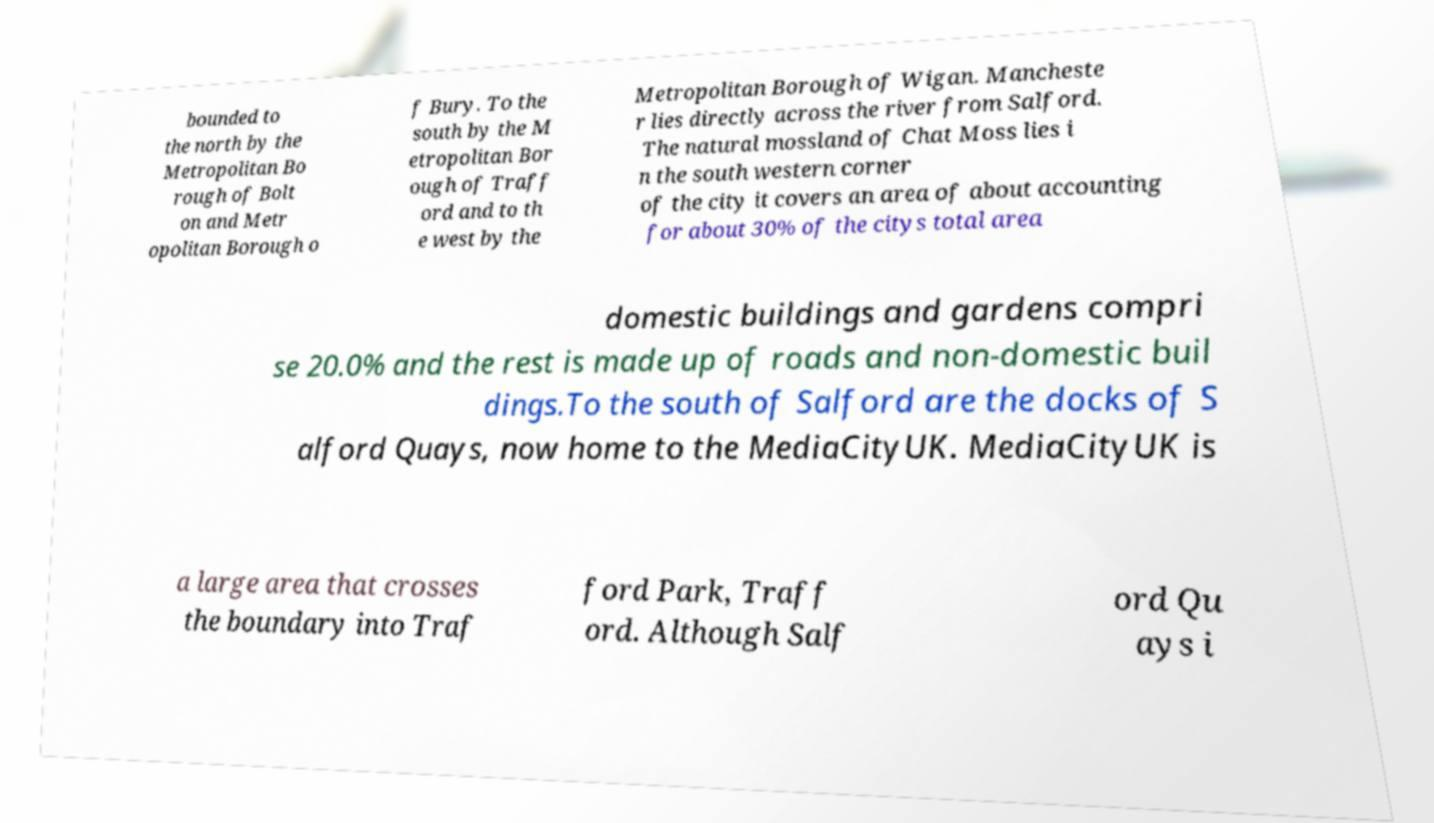Please identify and transcribe the text found in this image. bounded to the north by the Metropolitan Bo rough of Bolt on and Metr opolitan Borough o f Bury. To the south by the M etropolitan Bor ough of Traff ord and to th e west by the Metropolitan Borough of Wigan. Mancheste r lies directly across the river from Salford. The natural mossland of Chat Moss lies i n the south western corner of the city it covers an area of about accounting for about 30% of the citys total area domestic buildings and gardens compri se 20.0% and the rest is made up of roads and non-domestic buil dings.To the south of Salford are the docks of S alford Quays, now home to the MediaCityUK. MediaCityUK is a large area that crosses the boundary into Traf ford Park, Traff ord. Although Salf ord Qu ays i 